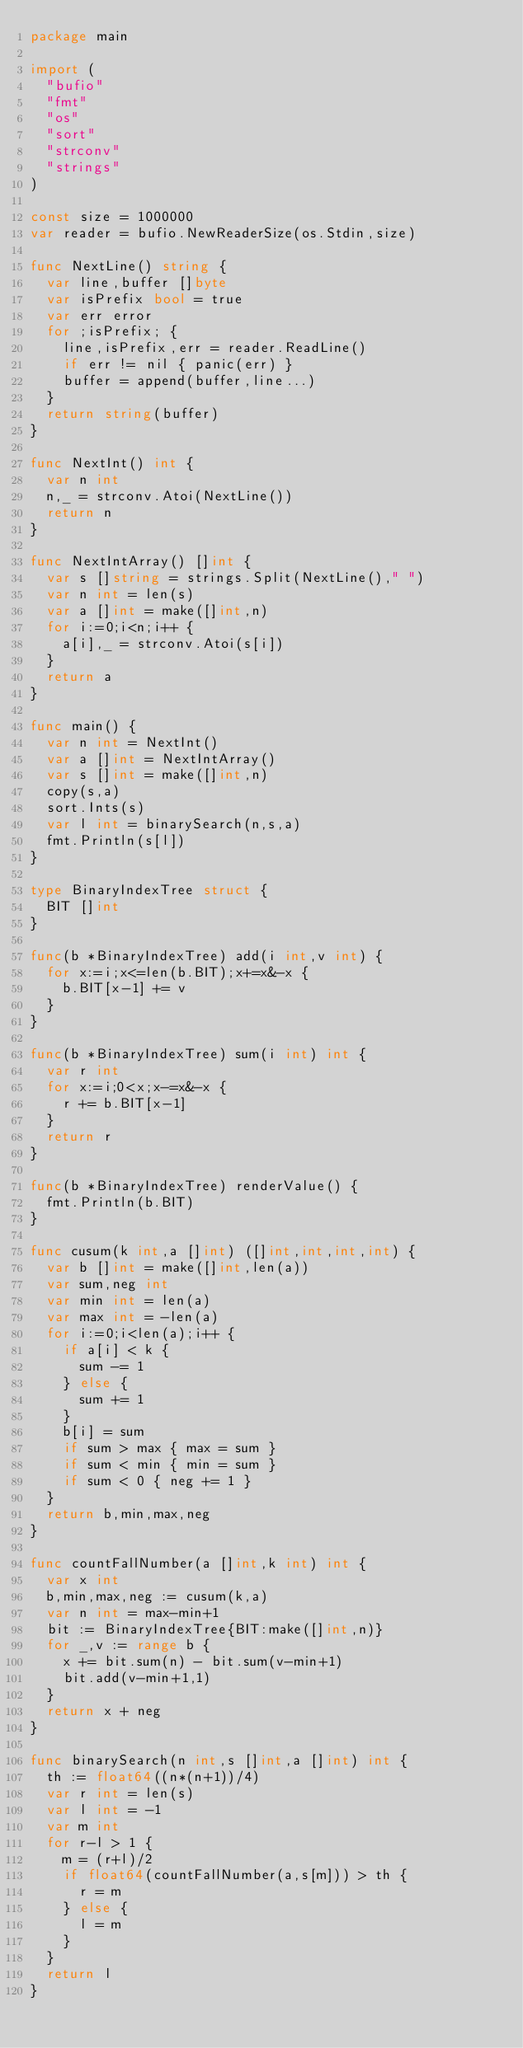Convert code to text. <code><loc_0><loc_0><loc_500><loc_500><_Go_>package main

import (
  "bufio"
  "fmt"
  "os"
  "sort"
  "strconv"
  "strings"
)

const size = 1000000
var reader = bufio.NewReaderSize(os.Stdin,size)

func NextLine() string {
  var line,buffer []byte
  var isPrefix bool = true
  var err error
  for ;isPrefix; {
    line,isPrefix,err = reader.ReadLine()
    if err != nil { panic(err) }
    buffer = append(buffer,line...)
  }
  return string(buffer)
}

func NextInt() int {
  var n int
  n,_ = strconv.Atoi(NextLine())
  return n
}

func NextIntArray() []int {
  var s []string = strings.Split(NextLine()," ")
  var n int = len(s)
  var a []int = make([]int,n)
  for i:=0;i<n;i++ {
    a[i],_ = strconv.Atoi(s[i])
  }
  return a
}

func main() {
  var n int = NextInt()
  var a []int = NextIntArray()
  var s []int = make([]int,n)
  copy(s,a)
  sort.Ints(s)
  var l int = binarySearch(n,s,a)
  fmt.Println(s[l])
}

type BinaryIndexTree struct {
  BIT []int
}

func(b *BinaryIndexTree) add(i int,v int) {
  for x:=i;x<=len(b.BIT);x+=x&-x {
    b.BIT[x-1] += v
  }
}

func(b *BinaryIndexTree) sum(i int) int {
  var r int
  for x:=i;0<x;x-=x&-x {
    r += b.BIT[x-1]
  }
  return r
}

func(b *BinaryIndexTree) renderValue() {
  fmt.Println(b.BIT)
}

func cusum(k int,a []int) ([]int,int,int,int) {
  var b []int = make([]int,len(a))
  var sum,neg int
  var min int = len(a)
  var max int = -len(a)
  for i:=0;i<len(a);i++ {
    if a[i] < k {
      sum -= 1 
    } else {
      sum += 1 
    }
    b[i] = sum
    if sum > max { max = sum }
    if sum < min { min = sum }
    if sum < 0 { neg += 1 }
  }
  return b,min,max,neg
}

func countFallNumber(a []int,k int) int {
  var x int
  b,min,max,neg := cusum(k,a)
  var n int = max-min+1
  bit := BinaryIndexTree{BIT:make([]int,n)}
  for _,v := range b {
    x += bit.sum(n) - bit.sum(v-min+1)
    bit.add(v-min+1,1)
  }
  return x + neg
}

func binarySearch(n int,s []int,a []int) int {
  th := float64((n*(n+1))/4)
  var r int = len(s)
  var l int = -1
  var m int
  for r-l > 1 {
    m = (r+l)/2
    if float64(countFallNumber(a,s[m])) > th { 
      r = m 
    } else {
      l = m 
    }
  }
  return l
}</code> 